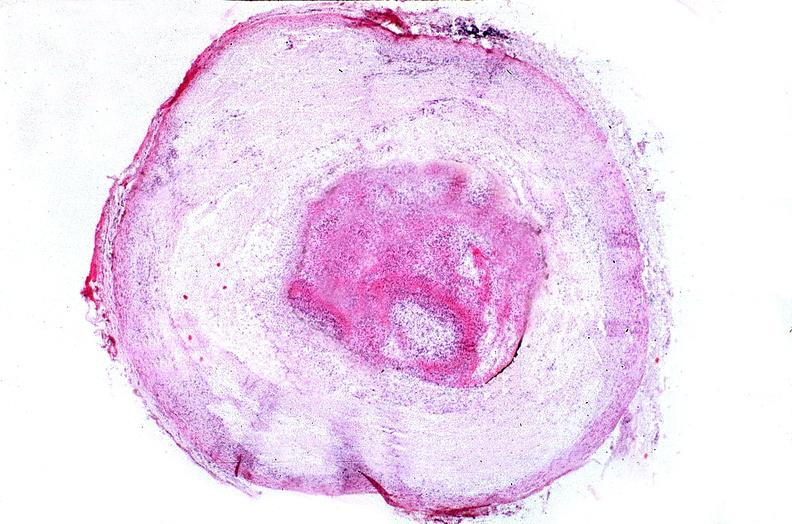s polycystic disease present?
Answer the question using a single word or phrase. No 